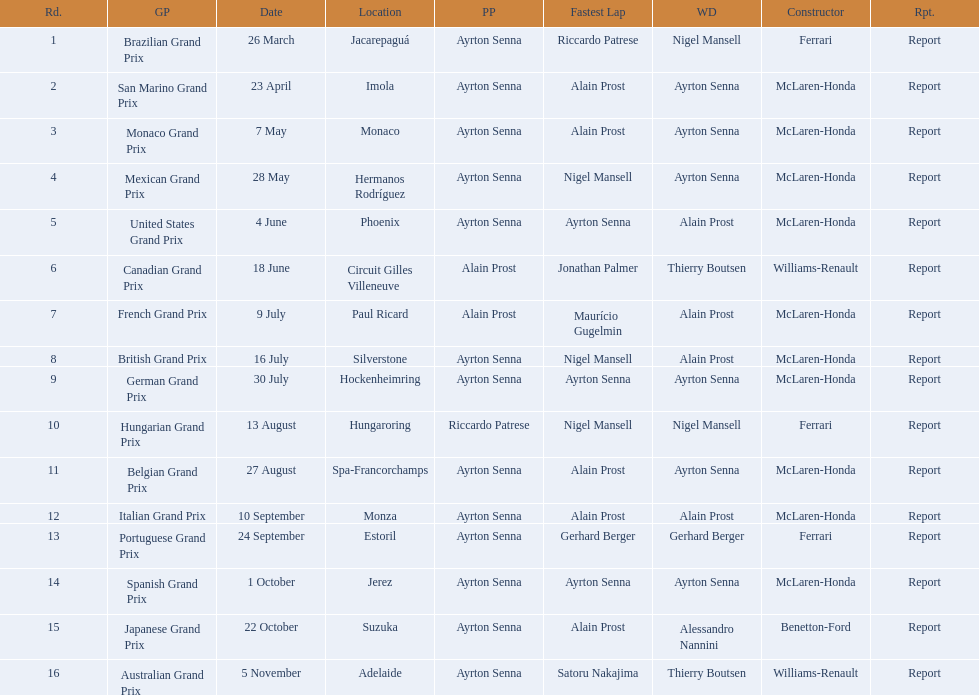How many did alain prost have the fastest lap? 5. 